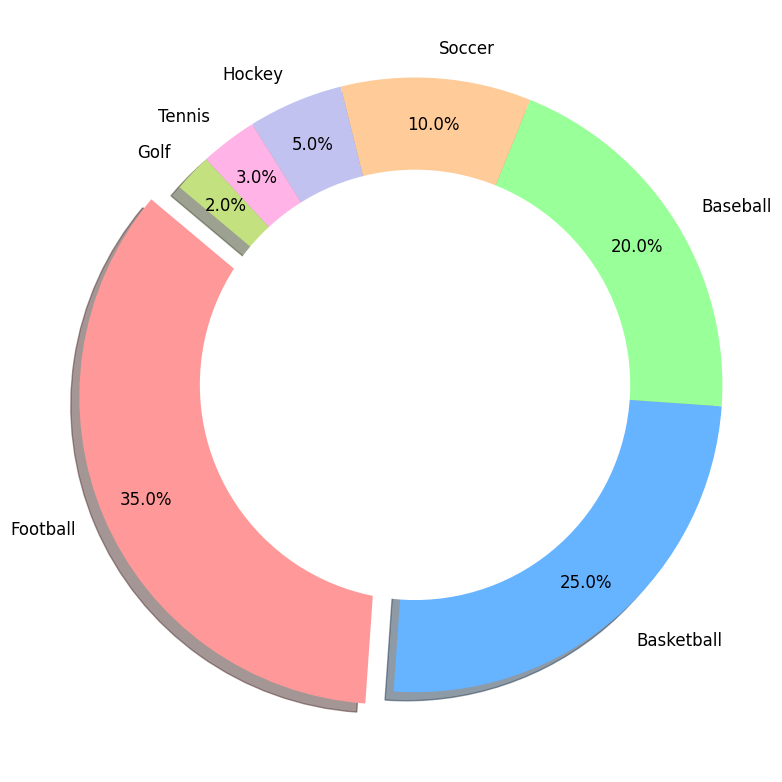What sport occupies the largest proportion in the pie chart? The largest proportion is represented by the slice that stands out with an explosion and has the highest percentage label. In this chart, it’s clear that Football occupies the largest proportion.
Answer: Football Which two sports combined make up half of the pie chart? To determine which two sports combined make up half of the pie chart, we look for percentages that add up to 50%. Football and Basketball together make up 35% + 25% = 60%, which is more than half. We need Football and Baseball, which add up to 35% + 20% = 55%, which is more than half. Basketball and Baseball alone make a combination of 25% + 20% = 45%, which is less than half. Therefore, no two sports exactly make up half. The best sum closest to half is Football and Basketball.
Answer: Football and Basketball What are the three sports with the smallest proportions in the chart? The three smallest portions of the pie chart are represented by the slices with the smallest percentages. Here, Golf (2%), Tennis (3%), and Hockey (5%) are the three smallest proportions.
Answer: Golf, Tennis, Hockey How much larger is the proportion of Football compared to Soccer? Determine the difference in percentages between Football and Soccer by subtracting Soccer’s proportion from Football’s proportion: 35% - 10% = 25%.
Answer: 25% If the proportion of Basketball was increased by 10%, would it surpass Football? To find out, first add 10% to the Basketball proportion, which gives 25% + 10% = 35%. Since Football is also at 35%, Basketball would equal, but not surpass, Football.
Answer: No What's the total proportion of Baseball, Hockey, and Golf combined? Add the proportions of Baseball (20%), Hockey (5%), and Golf (2%) together to find the total proportion: 20% + 5% + 2% = 27%.
Answer: 27% Which sport has a proportion three times larger than Golf? To find a sport with a proportion three times bigger than Golf's 2%, calculate 2% * 3 = 6%. Lookup the chart and Hockey has a 5% proportion but one sport has a proportion close to three times greater: Tennis has a proportion of 3%, so Baseball at 20% is more than three times 2%. But Hockey is the closest.
Answer: None (Direct exact 3 times match doesn't exist) What percentage of the pie chart is occupied by sports other than the top three? To find this, first identify the top three sports: Football (35%), Basketball (25%), Baseball (20%). Summing these, 35% + 25% + 20% = 80%. Then, subtract from 100% to get the proportion of the other sports: 100% - 80% = 20%.
Answer: 20% Between which sports is the difference in proportion of 15% observed in the chart? By comparing the different proportions in the chart, Basketball (25%) and Soccer (10%) have a difference of 15% (25% - 10% = 15%).
Answer: Basketball and Soccer 